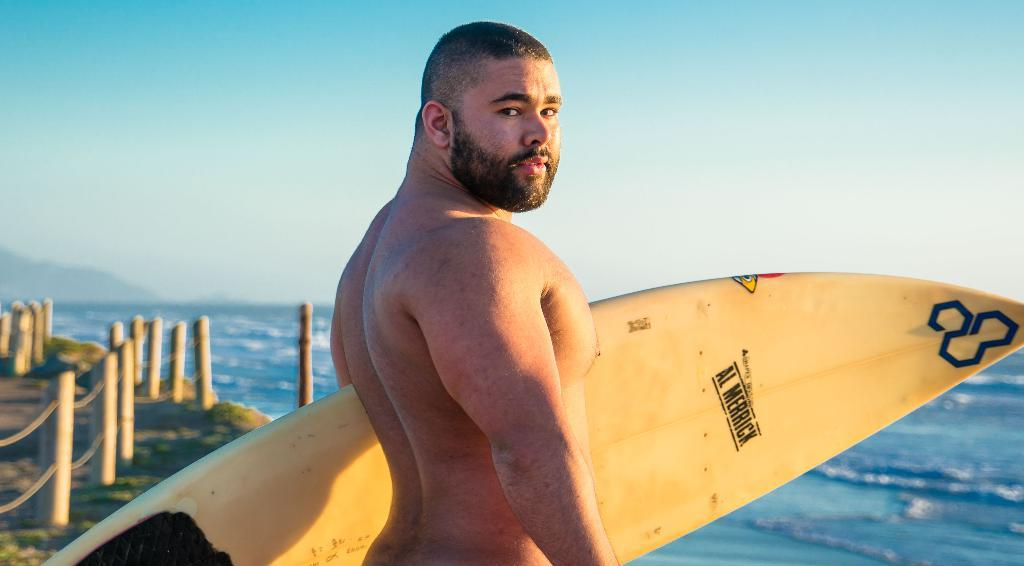Who or what is present in the image? There is a person in the image. What is the person holding in the image? The person is holding a surfing board. What type of environment is visible in the image? There is water and sky visible in the image. What type of straw is the person using to escape the jail in the image? There is no jail or straw present in the image; it features a person holding a surfing board in a water and sky environment. 